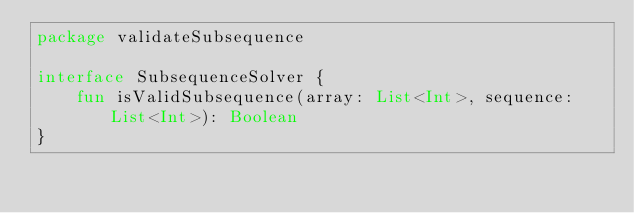<code> <loc_0><loc_0><loc_500><loc_500><_Kotlin_>package validateSubsequence

interface SubsequenceSolver {
    fun isValidSubsequence(array: List<Int>, sequence: List<Int>): Boolean
}</code> 